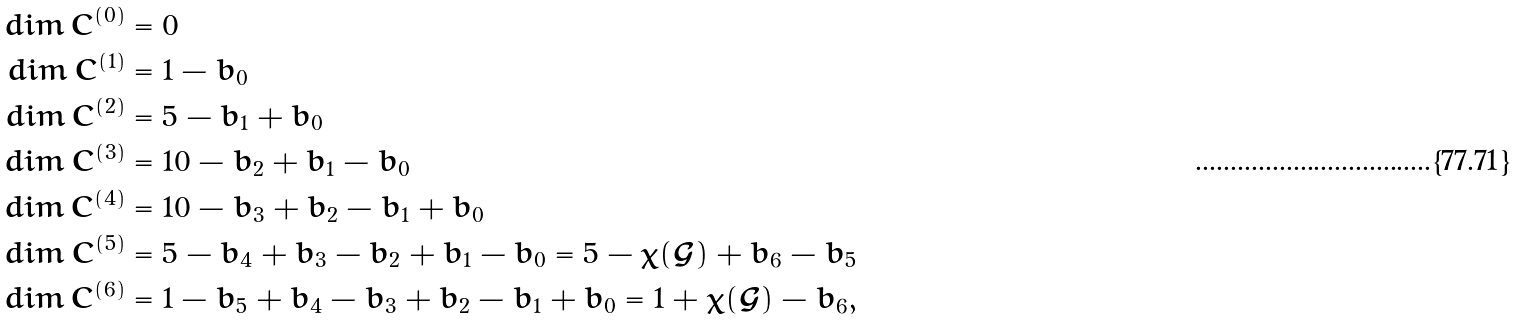<formula> <loc_0><loc_0><loc_500><loc_500>d i m \, C ^ { ( 0 ) } & = 0 \\ d i m \, C ^ { ( 1 ) } & = 1 - b _ { 0 } \\ d i m \, C ^ { ( 2 ) } & = 5 - b _ { 1 } + b _ { 0 } \\ d i m \, C ^ { ( 3 ) } & = 1 0 - b _ { 2 } + b _ { 1 } - b _ { 0 } \\ d i m \, C ^ { ( 4 ) } & = 1 0 - b _ { 3 } + b _ { 2 } - b _ { 1 } + b _ { 0 } \\ d i m \, C ^ { ( 5 ) } & = 5 - b _ { 4 } + b _ { 3 } - b _ { 2 } + b _ { 1 } - b _ { 0 } = 5 - \chi ( \mathcal { G } ) + b _ { 6 } - b _ { 5 } \\ d i m \, C ^ { ( 6 ) } & = 1 - b _ { 5 } + b _ { 4 } - b _ { 3 } + b _ { 2 } - b _ { 1 } + b _ { 0 } = 1 + \chi ( \mathcal { G } ) - b _ { 6 } ,</formula> 